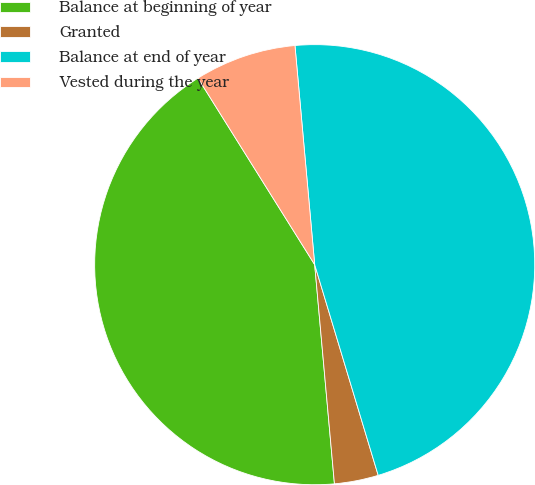<chart> <loc_0><loc_0><loc_500><loc_500><pie_chart><fcel>Balance at beginning of year<fcel>Granted<fcel>Balance at end of year<fcel>Vested during the year<nl><fcel>42.53%<fcel>3.23%<fcel>46.77%<fcel>7.47%<nl></chart> 